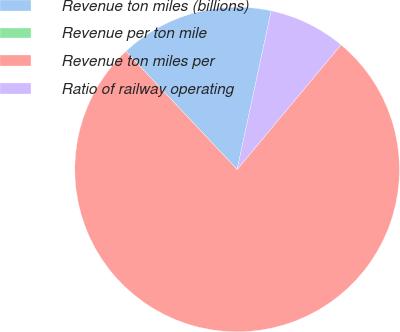Convert chart to OTSL. <chart><loc_0><loc_0><loc_500><loc_500><pie_chart><fcel>Revenue ton miles (billions)<fcel>Revenue per ton mile<fcel>Revenue ton miles per<fcel>Ratio of railway operating<nl><fcel>15.39%<fcel>0.0%<fcel>76.92%<fcel>7.69%<nl></chart> 